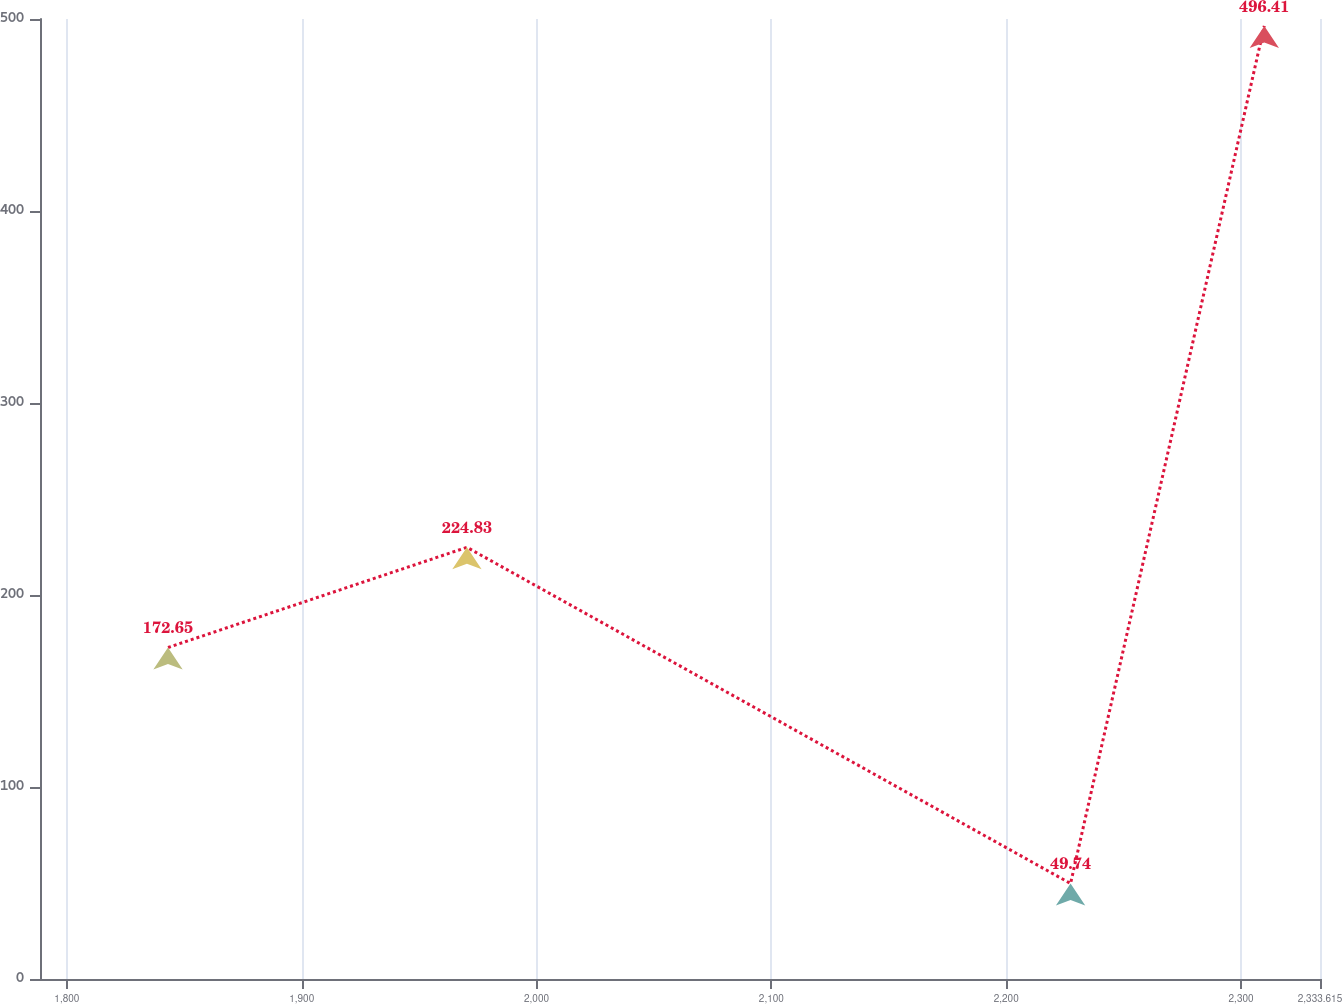<chart> <loc_0><loc_0><loc_500><loc_500><line_chart><ecel><fcel>(millions of dollars)<nl><fcel>1843.07<fcel>172.65<nl><fcel>1970.36<fcel>224.83<nl><fcel>2227.4<fcel>49.74<nl><fcel>2309.9<fcel>496.41<nl><fcel>2388.12<fcel>0.11<nl></chart> 